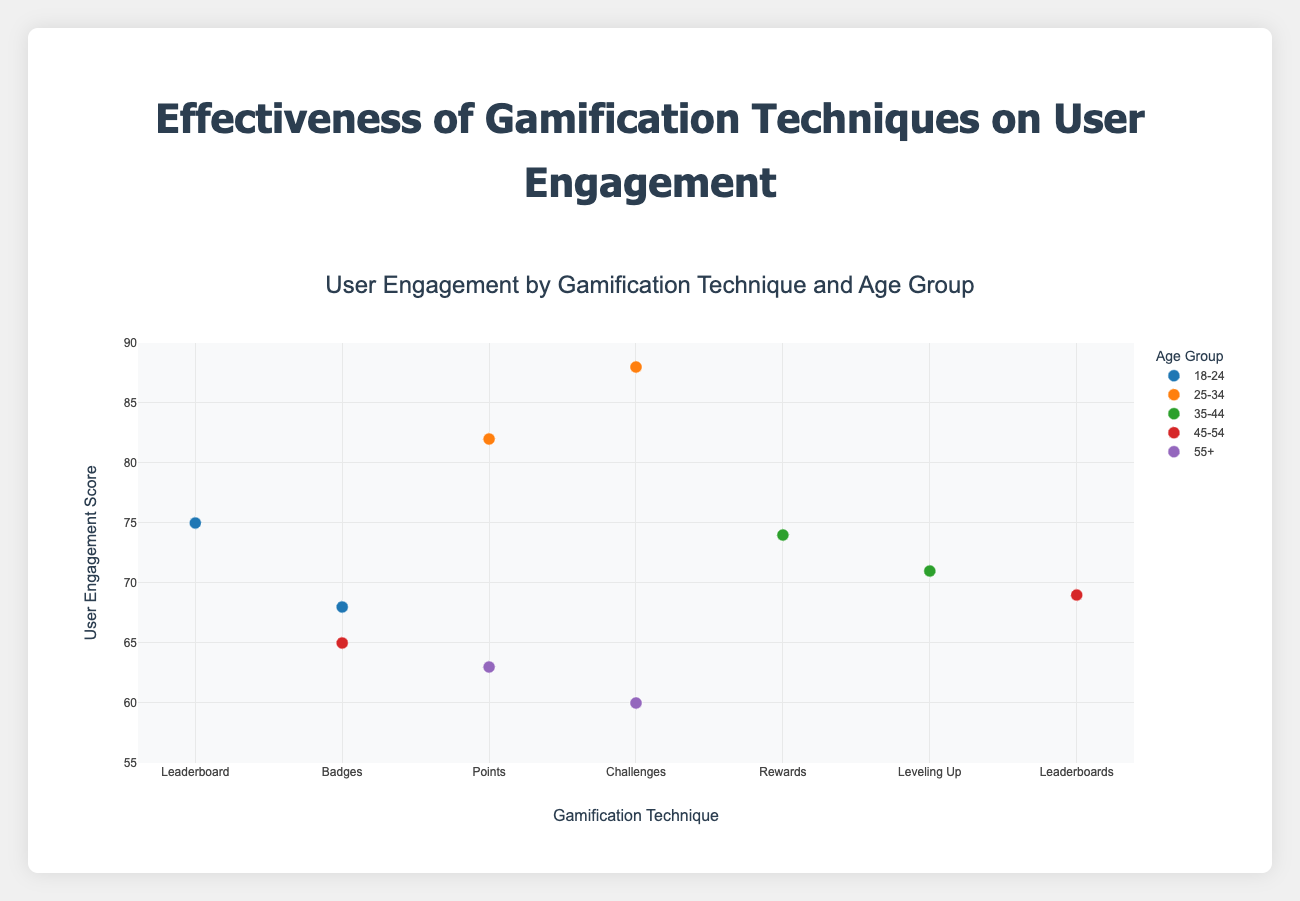What is the highest user engagement score across all age groups? To find the highest user engagement score, look at the y-axis values for all data points. The highest value is 88.
Answer: 88 Which gamification technique has the lowest user engagement score for the age group 55+? Focus on the points for the age group 55+ and their corresponding gamification techniques and user engagement values. The Points technique has the engagement score of 63, and Challenges has 60. The lowest is Challenges at 60.
Answer: Challenges How does the user engagement for Leaderboard in the 18-24 age group compare to the same technique in the 45-54 age group? Identify the Leaderboard data points for both age groups and compare their y-axis values. For 18-24, it's 75 and for 45-54, it's 69.
Answer: Leaderboard is higher for 18-24 What's the average user engagement score for the age group 25-34? Identify the scores for 25-34 which are 82 and 88. Add them together to get 170 and divide by 2 to get the average.
Answer: 85 Which mobile app has the highest user engagement score, and what is the score? Examine the text associated with the highest y-axis value data point. The highest score is from the mobile app "FitnessPro," which is 88.
Answer: FitnessPro, 88 Are there any age groups where all gamification techniques have user engagement scores above 70? Look at each age group’s scores. Both entries for 18-24 and 25-34 age groups are above 70.
Answer: Yes, 18-24 and 25-34 Which age group has the most diverse set of gamification techniques with respect to user engagement scores? Compare the number of unique gamification techniques per age group. Each has 2 data points (techniques) but check the engagement score ranges. 25-34 has 82 and 88 (most diverse).
Answer: 25-34 How many data points are there in total for the age group 35-44? Count the data points for the age group 35-44. There are 2 points.
Answer: 2 What is the difference in user engagement score between the highest and lowest scoring gamification techniques for the age group 35-44? The scores for 35-44 are 74 and 71. The difference is 3.
Answer: 3 Which age group has the highest average user engagement score overall? Calculate the average for each age group: 
18-24: (75+68)/2 = 71.5,
25-34: (82+88)/2 = 85,
35-44: (74+71)/2 = 72.5,
45-54: (69+65)/2 = 67,
55+: (63+60)/2 = 61.5.
25-34 has the highest average.
Answer: 25-34 